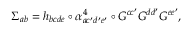Convert formula to latex. <formula><loc_0><loc_0><loc_500><loc_500>\Sigma _ { a b } = h _ { b c d e } \circ \alpha _ { a c ^ { \prime } d ^ { \prime } e ^ { \prime } } ^ { 4 } \circ G ^ { c c ^ { \prime } } G ^ { d d ^ { \prime } } G ^ { e e ^ { \prime } } ,</formula> 